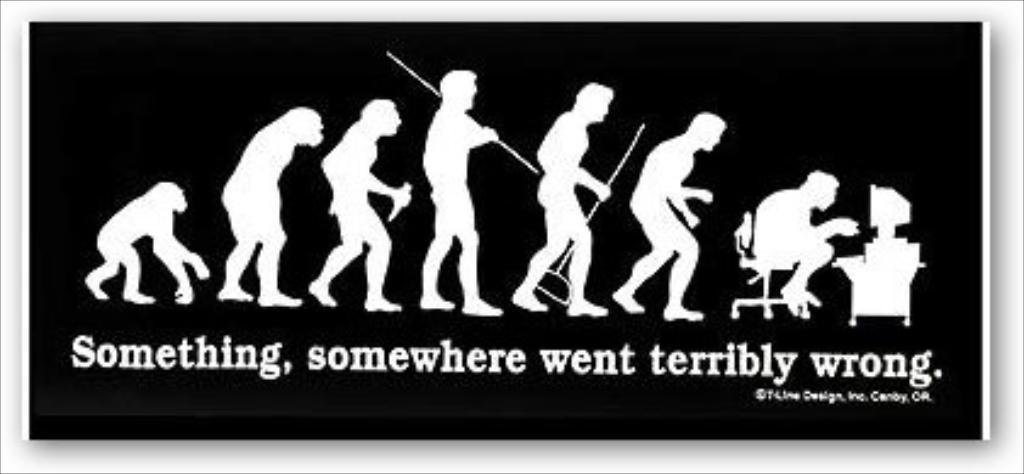Provide a one-sentence caption for the provided image. A sticker that reads Something, somewhere went terribly wrong. 